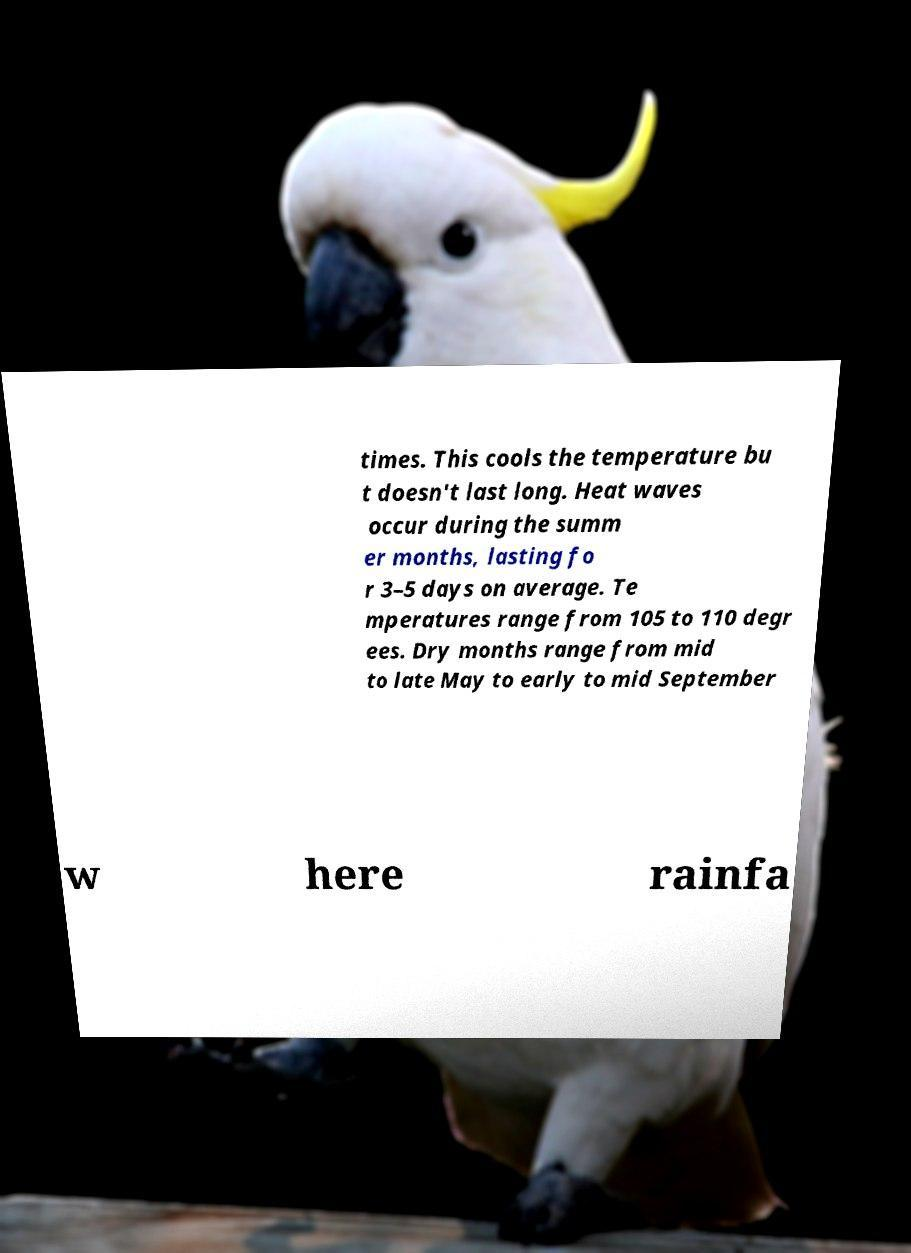I need the written content from this picture converted into text. Can you do that? times. This cools the temperature bu t doesn't last long. Heat waves occur during the summ er months, lasting fo r 3–5 days on average. Te mperatures range from 105 to 110 degr ees. Dry months range from mid to late May to early to mid September w here rainfa 